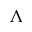Convert formula to latex. <formula><loc_0><loc_0><loc_500><loc_500>\Lambda</formula> 